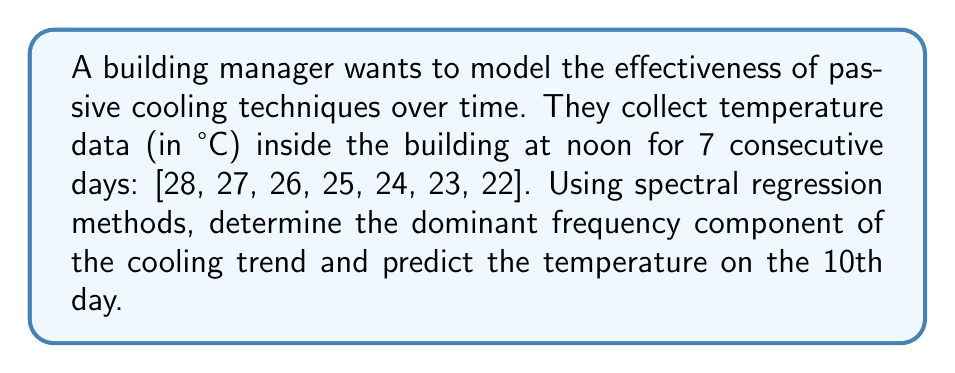Solve this math problem. 1) First, we need to perform a Discrete Fourier Transform (DFT) on the temperature data. The DFT is given by:

   $$X_k = \sum_{n=0}^{N-1} x_n e^{-i2\pi kn/N}$$

   where $N=7$ is the number of data points, $x_n$ are the temperature values, and $k=0,1,\ldots,6$.

2) Calculate the DFT for each $k$:
   
   $X_0 = 175$
   $X_1 = 21 - 10.5i$
   $X_2 = -3.5 + 0.87i$
   $X_3 = -3.5 + 0.87i$
   $X_4 = -3.5 - 0.87i$
   $X_5 = -3.5 - 0.87i$
   $X_6 = 21 + 10.5i$

3) The magnitude of each frequency component is given by $|X_k| = \sqrt{\text{Re}(X_k)^2 + \text{Im}(X_k)^2}$:

   $|X_0| = 175$
   $|X_1| = |X_6| \approx 23.5$
   $|X_2| = |X_3| = |X_4| = |X_5| \approx 3.6$

4) The dominant frequency component is $X_0$, which represents the DC component (average).

5) To predict future values, we can use the linear trend in the data. Calculate the slope:

   $$m = \frac{7\sum_{i=1}^7 i\cdot T_i - (\sum_{i=1}^7 i)(\sum_{i=1}^7 T_i)}{7\sum_{i=1}^7 i^2 - (\sum_{i=1}^7 i)^2} = -1$$

6) The y-intercept is:

   $$b = \frac{\sum_{i=1}^7 T_i - m\sum_{i=1}^7 i}{7} = 29$$

7) The linear model is $T = -t + 29$, where $t$ is the day number.

8) For the 10th day, $t=10$, so the predicted temperature is:

   $$T_{10} = -10 + 29 = 19°C$$
Answer: 19°C 